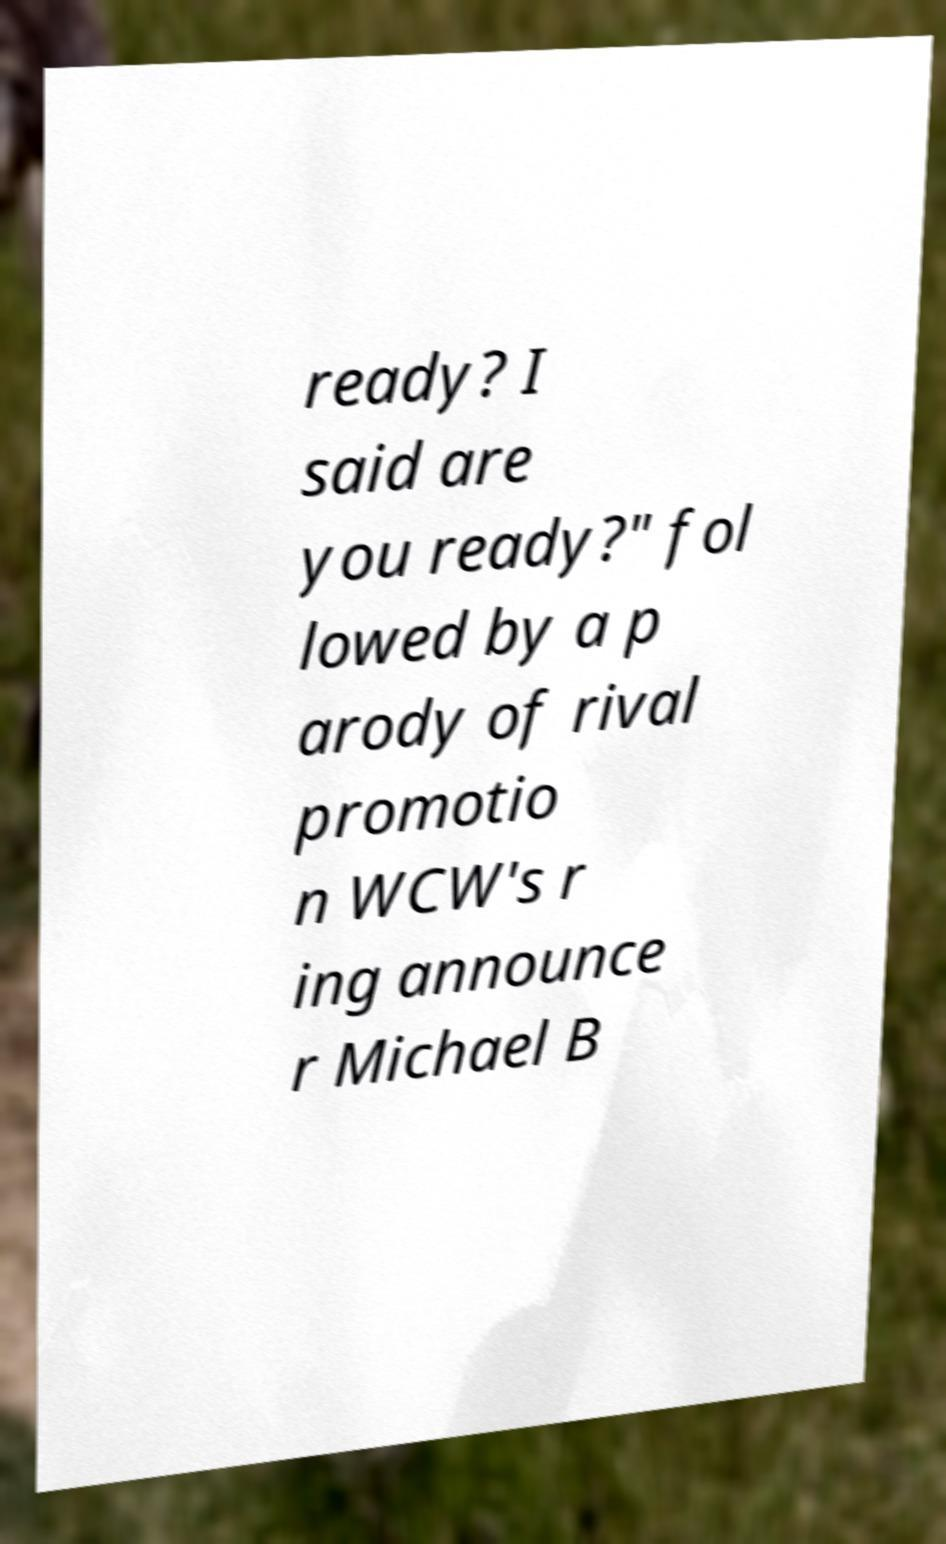Please identify and transcribe the text found in this image. ready? I said are you ready?" fol lowed by a p arody of rival promotio n WCW's r ing announce r Michael B 